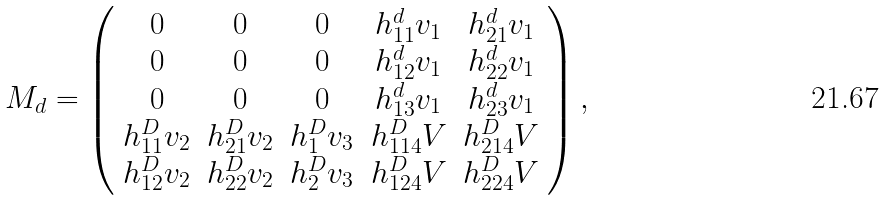<formula> <loc_0><loc_0><loc_500><loc_500>M _ { d } = \left ( \begin{array} { c c c c c } 0 & 0 & 0 & h _ { 1 1 } ^ { d } v _ { 1 } & h _ { 2 1 } ^ { d } v _ { 1 } \\ 0 & 0 & 0 & h _ { 1 2 } ^ { d } v _ { 1 } & h _ { 2 2 } ^ { d } v _ { 1 } \\ 0 & 0 & 0 & h _ { 1 3 } ^ { d } v _ { 1 } & h _ { 2 3 } ^ { d } v _ { 1 } \\ h _ { 1 1 } ^ { D } v _ { 2 } & h _ { 2 1 } ^ { D } v _ { 2 } & h _ { 1 } ^ { D } v _ { 3 } & h _ { 1 1 4 } ^ { D } V & h _ { 2 1 4 } ^ { D } V \\ h _ { 1 2 } ^ { D } v _ { 2 } & h _ { 2 2 } ^ { D } v _ { 2 } & h _ { 2 } ^ { D } v _ { 3 } & h _ { 1 2 4 } ^ { D } V & h _ { 2 2 4 } ^ { D } V \\ \end{array} \right ) ,</formula> 